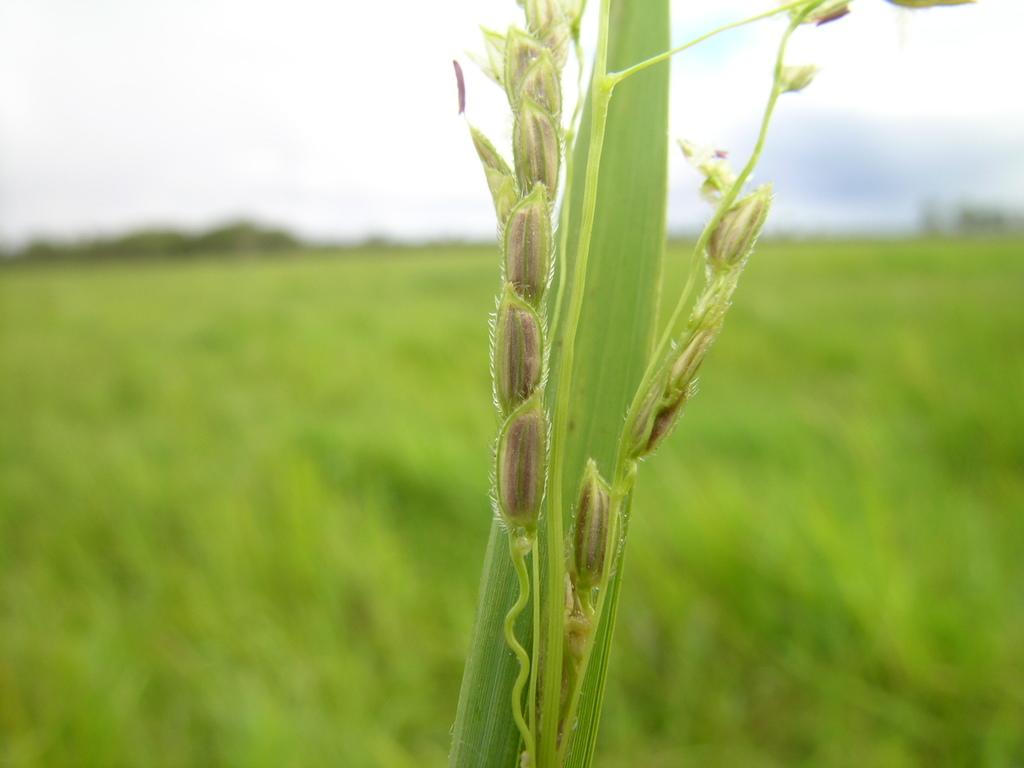What is located in the foreground of the image? There is a plant and seeds in the foreground of the image. What else can be seen in the foreground besides the plant? There are seeds visible in the foreground. What is visible in the background of the image? There are plants, trees, and the sky visible in the background of the image. Can you describe the vegetation in the background? The background includes plants and trees. Where is the throne located in the image? There is no throne present in the image. What impulse might the plants in the image have? Plants do not have impulses, as they are inanimate objects. What reason might the trees in the background have for being there? Trees do not have reasons for being in the image, as they are a natural part of the environment. 